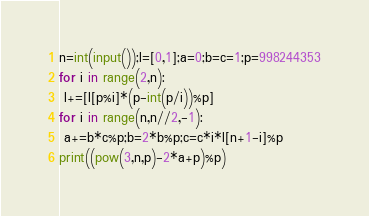<code> <loc_0><loc_0><loc_500><loc_500><_Python_>n=int(input());l=[0,1];a=0;b=c=1;p=998244353
for i in range(2,n):
 l+=[l[p%i]*(p-int(p/i))%p]
for i in range(n,n//2,-1):
 a+=b*c%p;b=2*b%p;c=c*i*l[n+1-i]%p
print((pow(3,n,p)-2*a+p)%p)</code> 